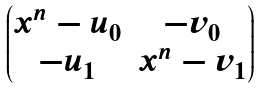Convert formula to latex. <formula><loc_0><loc_0><loc_500><loc_500>\begin{pmatrix} x ^ { n } - u _ { 0 } & - v _ { 0 } \\ - u _ { 1 } & x ^ { n } - v _ { 1 } \end{pmatrix}</formula> 